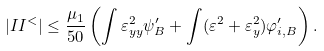Convert formula to latex. <formula><loc_0><loc_0><loc_500><loc_500>| I I ^ { < } | \leq \frac { \mu _ { 1 } } { 5 0 } \left ( \int \varepsilon ^ { 2 } _ { y y } \psi _ { B } ^ { \prime } + \int ( \varepsilon ^ { 2 } + \varepsilon _ { y } ^ { 2 } ) \varphi _ { i , B } ^ { \prime } \right ) .</formula> 